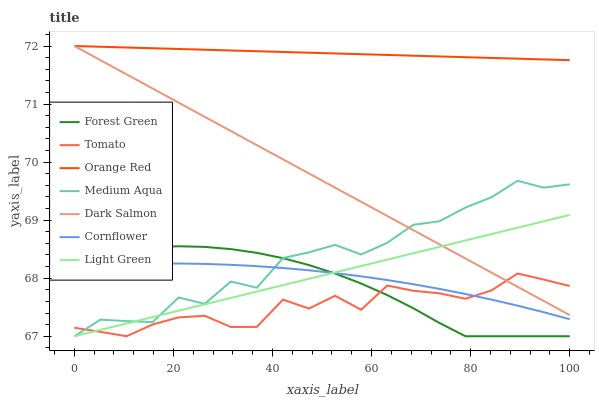Does Tomato have the minimum area under the curve?
Answer yes or no. Yes. Does Cornflower have the minimum area under the curve?
Answer yes or no. No. Does Cornflower have the maximum area under the curve?
Answer yes or no. No. Is Cornflower the smoothest?
Answer yes or no. No. Is Cornflower the roughest?
Answer yes or no. No. Does Cornflower have the lowest value?
Answer yes or no. No. Does Cornflower have the highest value?
Answer yes or no. No. Is Medium Aqua less than Orange Red?
Answer yes or no. Yes. Is Orange Red greater than Light Green?
Answer yes or no. Yes. Does Medium Aqua intersect Orange Red?
Answer yes or no. No. 